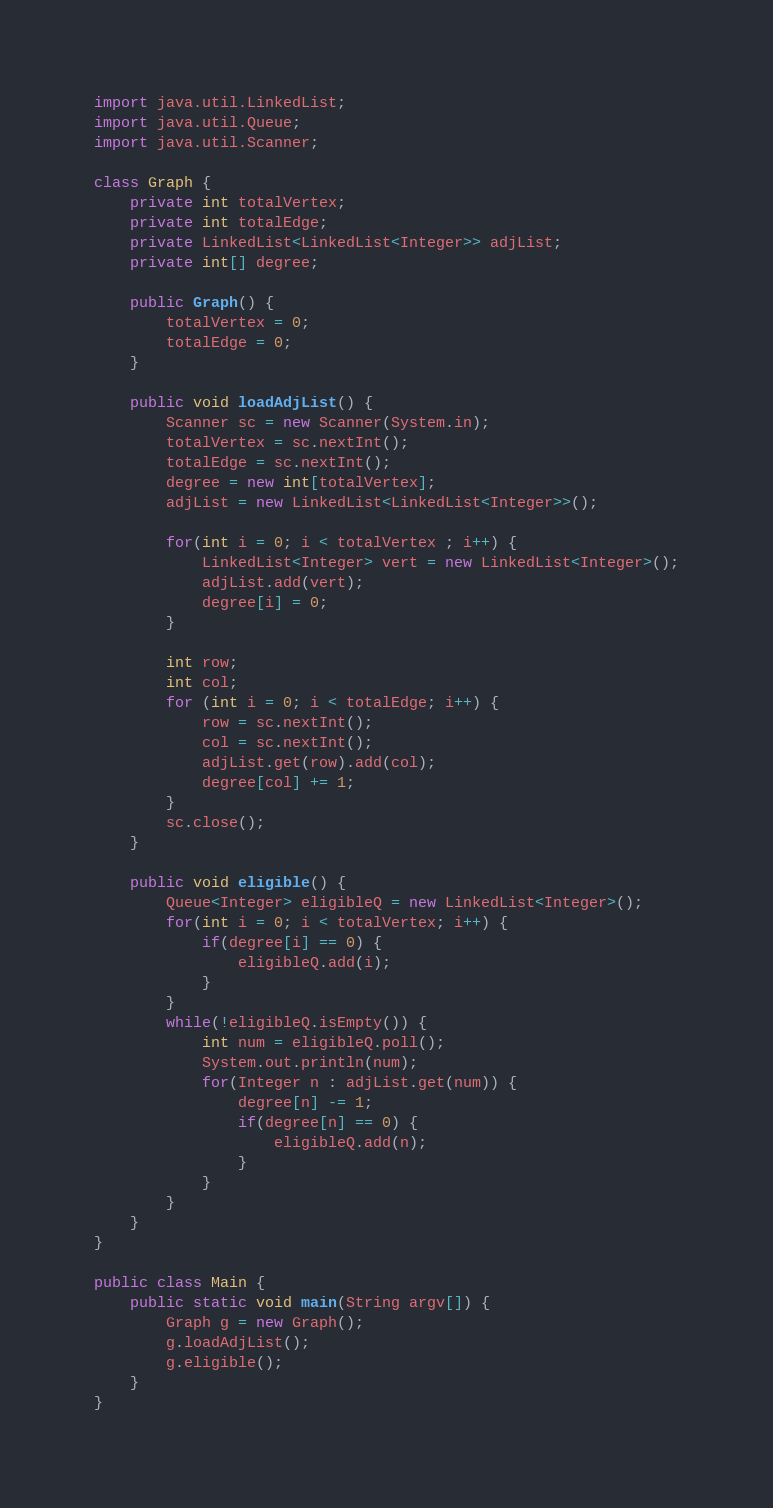<code> <loc_0><loc_0><loc_500><loc_500><_Java_>import java.util.LinkedList;
import java.util.Queue;
import java.util.Scanner;

class Graph {
	private int totalVertex;
	private int totalEdge;
	private LinkedList<LinkedList<Integer>> adjList;
	private int[] degree;

	public Graph() {
		totalVertex = 0;
		totalEdge = 0;
	}

	public void loadAdjList() {
		Scanner sc = new Scanner(System.in);
		totalVertex = sc.nextInt();
		totalEdge = sc.nextInt();
		degree = new int[totalVertex];
		adjList = new LinkedList<LinkedList<Integer>>();
		
		for(int i = 0; i < totalVertex ; i++) {
			LinkedList<Integer> vert = new LinkedList<Integer>();
			adjList.add(vert);
			degree[i] = 0;
		}
		
		int row;
		int col;
		for (int i = 0; i < totalEdge; i++) {
			row = sc.nextInt();
			col = sc.nextInt();
			adjList.get(row).add(col);
			degree[col] += 1;
		}
		sc.close();
	}
	
	public void eligible() {
		Queue<Integer> eligibleQ = new LinkedList<Integer>();
		for(int i = 0; i < totalVertex; i++) {
			if(degree[i] == 0) {
				eligibleQ.add(i);
			}
		}
		while(!eligibleQ.isEmpty()) {
			int num = eligibleQ.poll();
			System.out.println(num);
			for(Integer n : adjList.get(num)) {
				degree[n] -= 1;
				if(degree[n] == 0) {
					eligibleQ.add(n);
				}
			}
		}
	}
}

public class Main {
	public static void main(String argv[]) {
		Graph g = new Graph();
		g.loadAdjList();
		g.eligible();
	}
}
</code> 